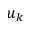Convert formula to latex. <formula><loc_0><loc_0><loc_500><loc_500>u _ { k }</formula> 